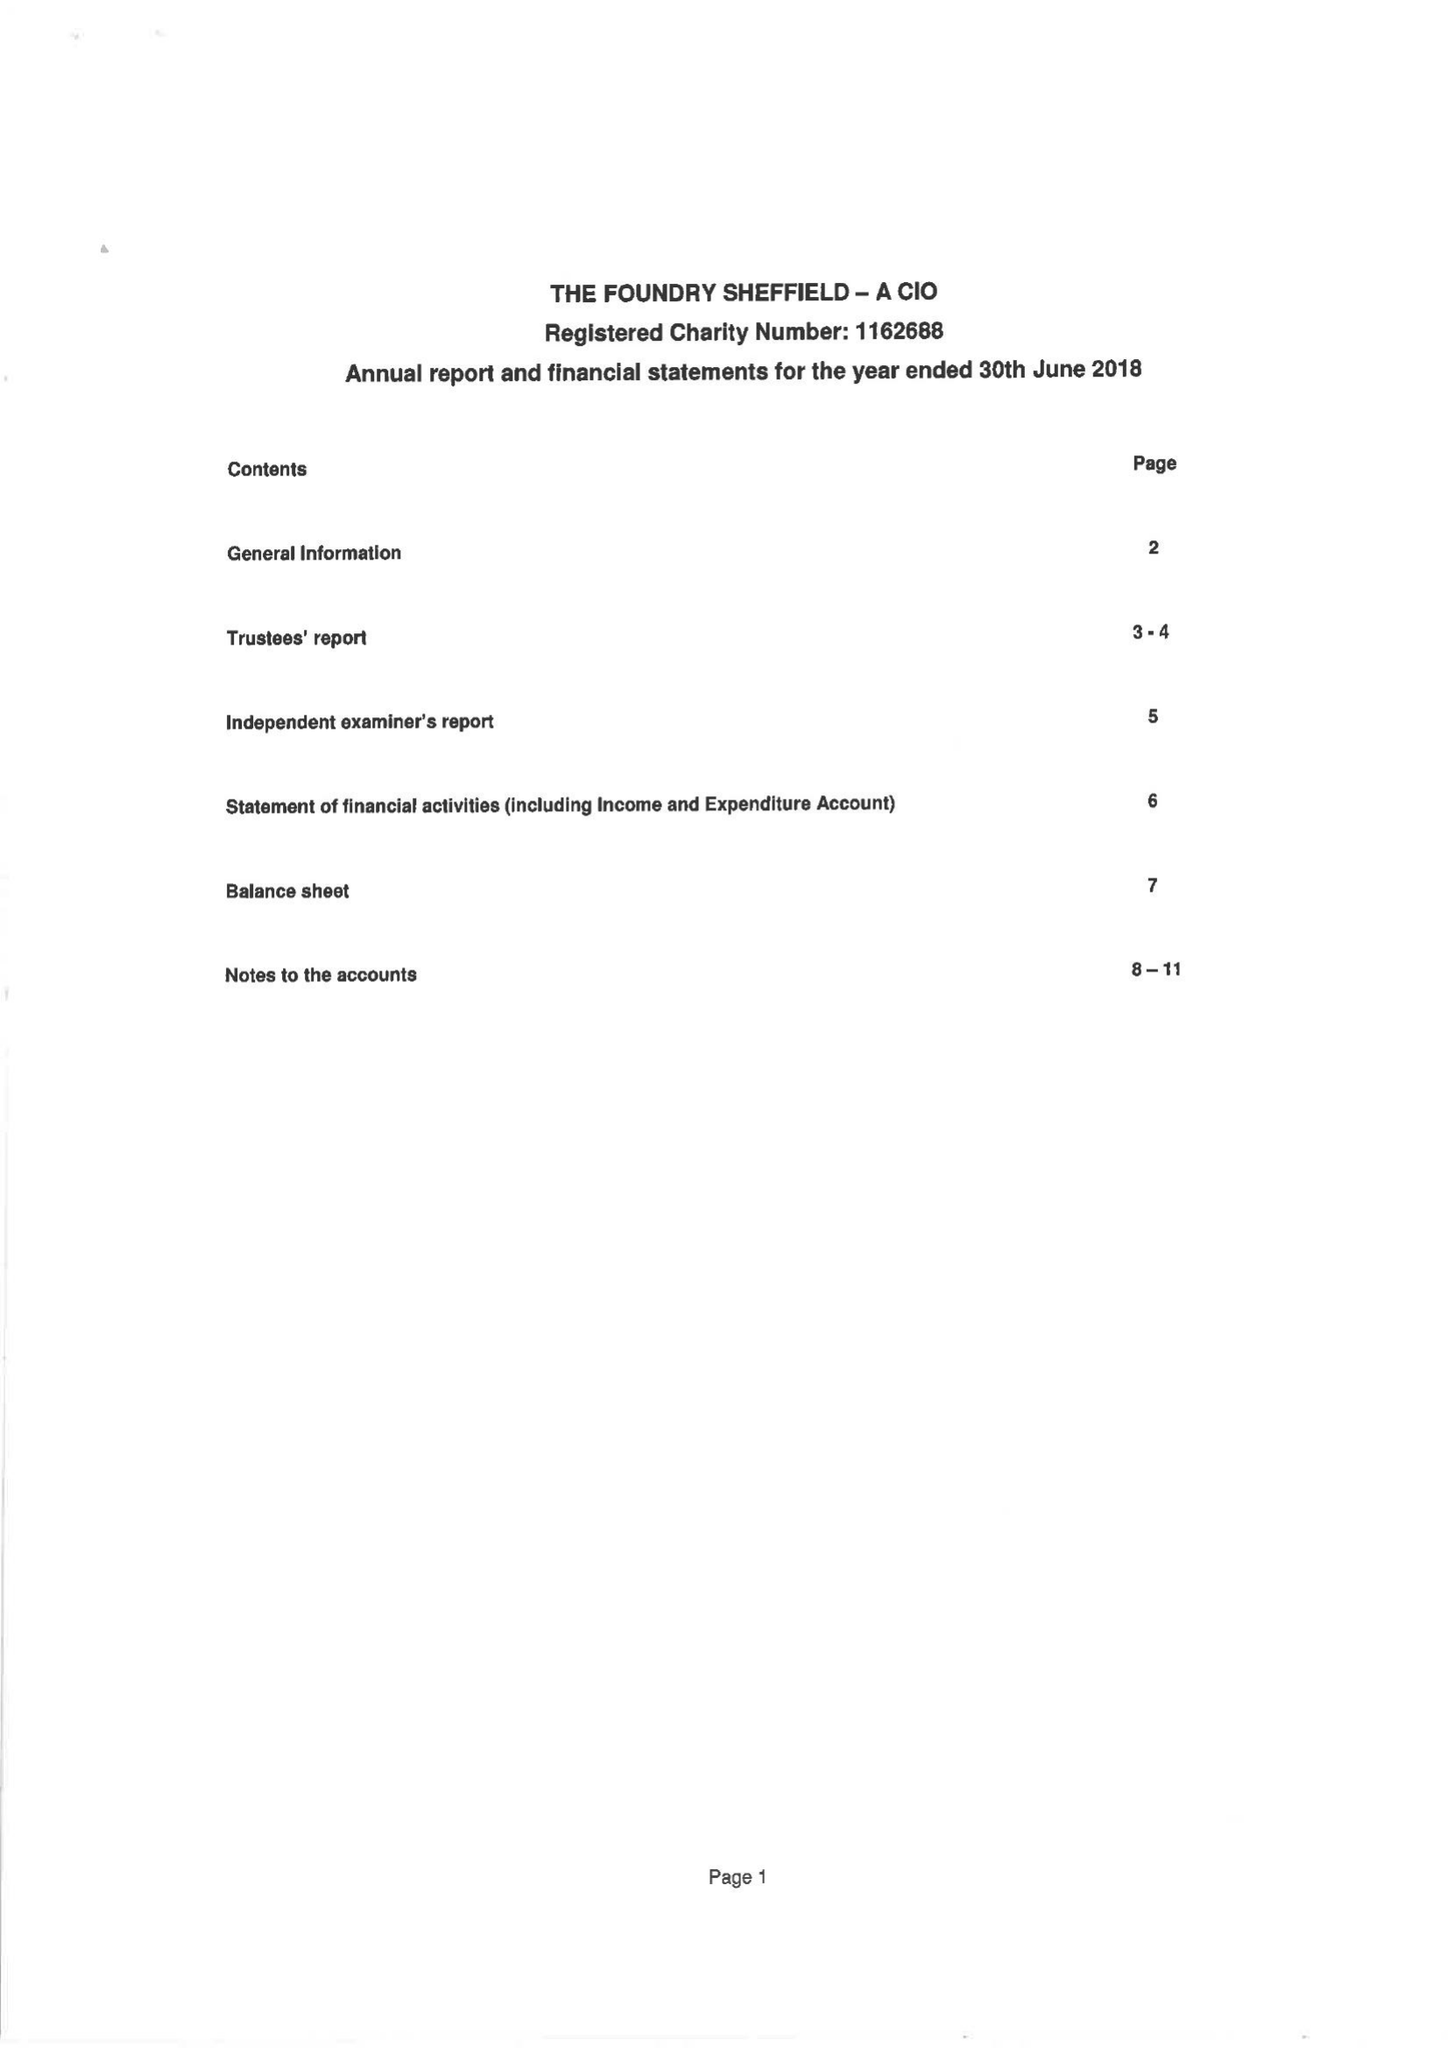What is the value for the charity_number?
Answer the question using a single word or phrase. 1162688 